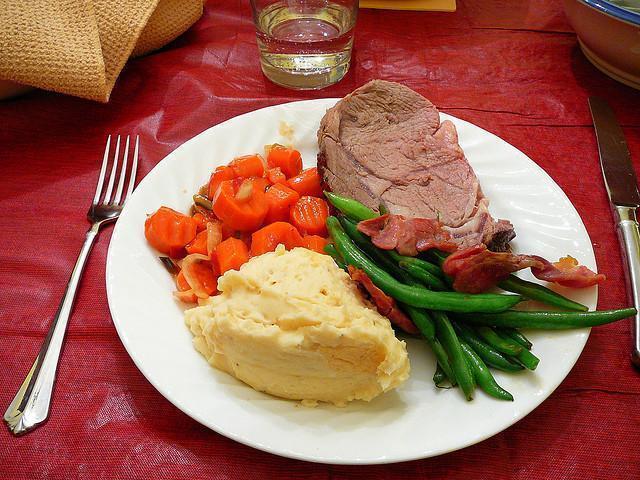What is a healthy item on the plate?
Choose the right answer and clarify with the format: 'Answer: answer
Rationale: rationale.'
Options: Chicken leg, lemon, guava, carrot. Answer: carrot.
Rationale: There are some orange carrots sliced up on the plate. 